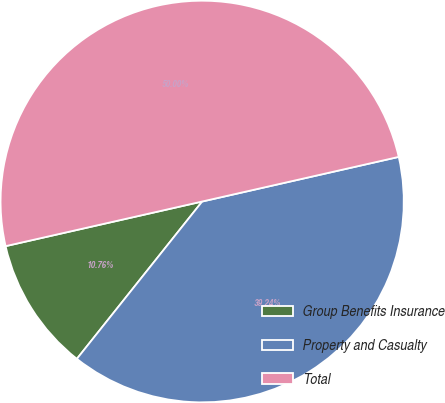Convert chart. <chart><loc_0><loc_0><loc_500><loc_500><pie_chart><fcel>Group Benefits Insurance<fcel>Property and Casualty<fcel>Total<nl><fcel>10.76%<fcel>39.24%<fcel>50.0%<nl></chart> 